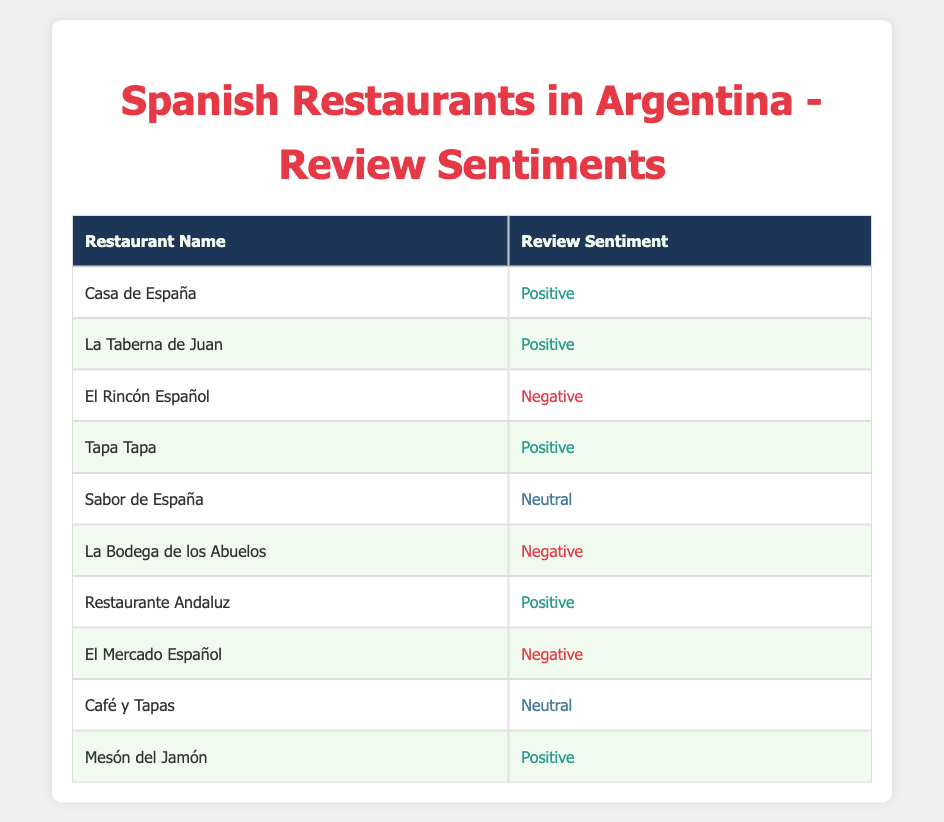What is the total number of restaurants listed in the table? There are 10 restaurants listed in the table, as you can count each entry under the "Restaurant Name" column.
Answer: 10 How many restaurants received a Positive review sentiment? There are 5 restaurants that received a Positive sentiment: Casa de España, La Taberna de Juan, Tapa Tapa, Restaurante Andaluz, and Mesón del Jamón.
Answer: 5 Is "Café y Tapas" categorized as Negative? Looking at the review sentiment for Café y Tapas, it is categorized as Neutral, not Negative. Therefore, the statement is false.
Answer: No What percentage of the restaurants are rated Neutral? There are 2 Neutral reviews among a total of 10 restaurants. To find the percentage, divide 2 by 10 and multiply by 100, which equals 20%.
Answer: 20% Which restaurant received a Negative review sentiment? The restaurants that received a Negative sentiment are El Rincón Español, La Bodega de los Abuelos, and El Mercado Español. You can find them listed in the table under the Review Sentiment column.
Answer: El Rincón Español, La Bodega de los Abuelos, El Mercado Español How many more Positive reviews are there than Neutral reviews? There are 5 Positive reviews and 2 Neutral reviews. To find the difference, subtract 2 from 5, which results in 3 more Positive reviews.
Answer: 3 Are there any restaurants that received only Neutral reviews? Looking through the table, the only restaurants that received a Neutral review are Sabor de España and Café y Tapas. As such, the answer is yes, but they are not the only ones if we consider Neutral reviews as a category.
Answer: Yes What is the total count of Negative sentiments received by the restaurants? From the table, we can see there are 3 Negative sentiments: from El Rincón Español, La Bodega de los Abuelos, and El Mercado Español. Therefore, the total is 3.
Answer: 3 Which restaurant has the most Positive reviews? All five restaurants have received Positive reviews, so it isn’t possible to single out one restaurant with the most, as they all tie in this category.
Answer: All have the same amount 